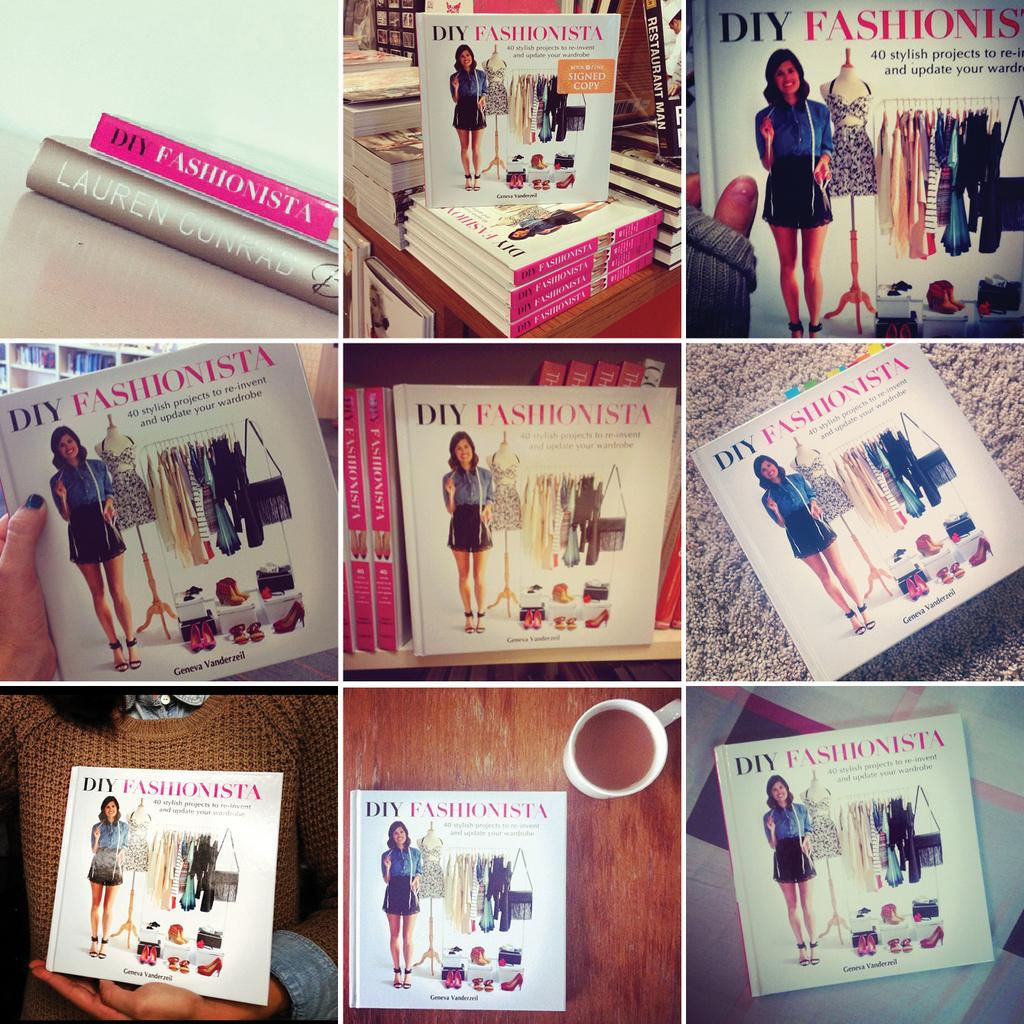<image>
Relay a brief, clear account of the picture shown. The DIY Fashionista book is displayed in nine separate instances. 